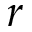Convert formula to latex. <formula><loc_0><loc_0><loc_500><loc_500>r</formula> 